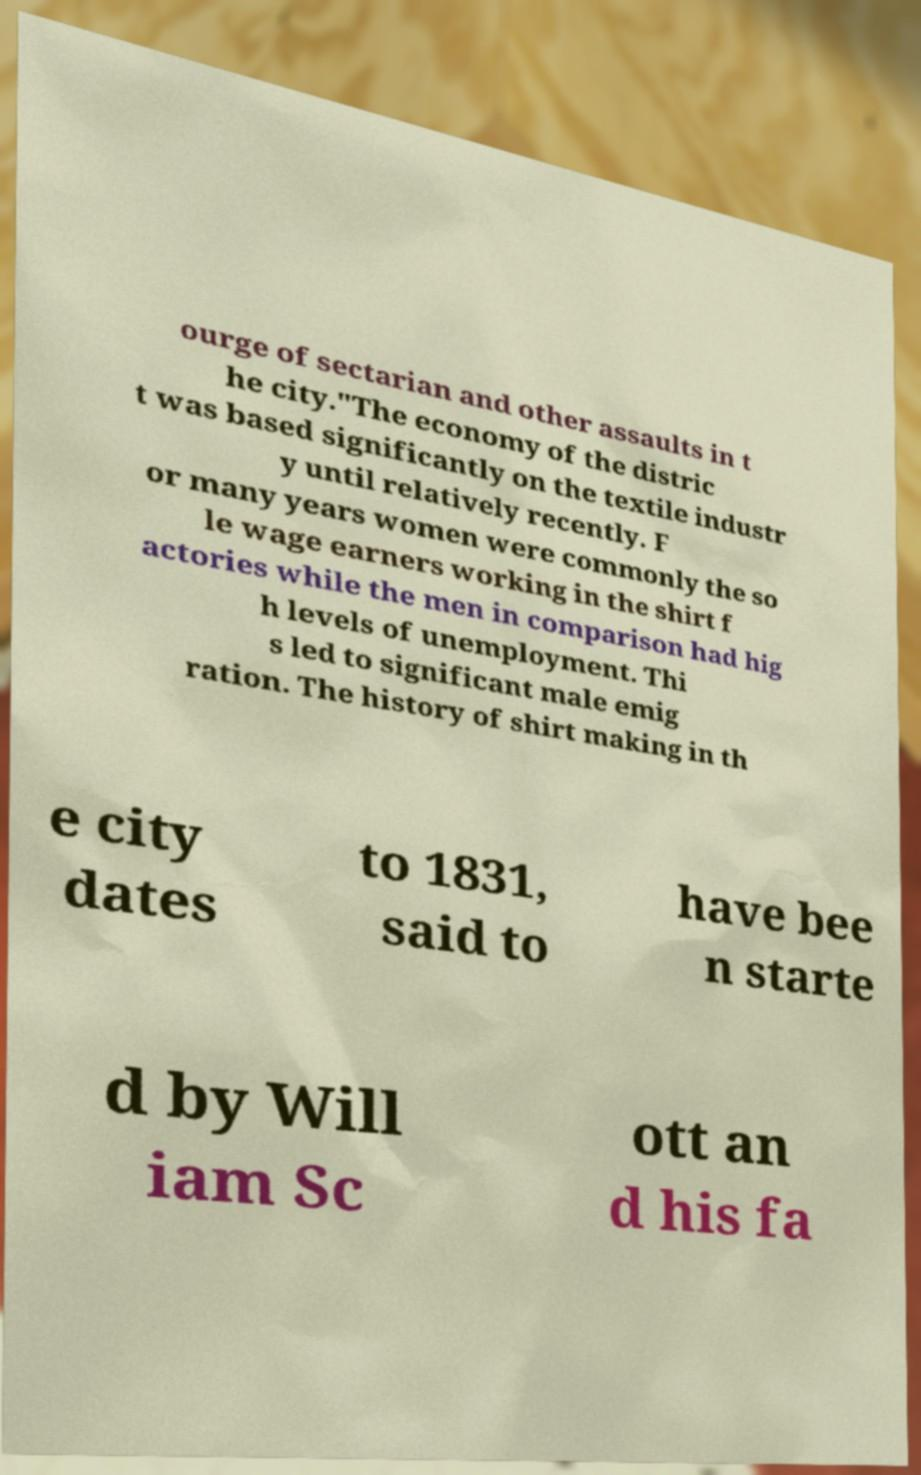Could you assist in decoding the text presented in this image and type it out clearly? ourge of sectarian and other assaults in t he city."The economy of the distric t was based significantly on the textile industr y until relatively recently. F or many years women were commonly the so le wage earners working in the shirt f actories while the men in comparison had hig h levels of unemployment. Thi s led to significant male emig ration. The history of shirt making in th e city dates to 1831, said to have bee n starte d by Will iam Sc ott an d his fa 